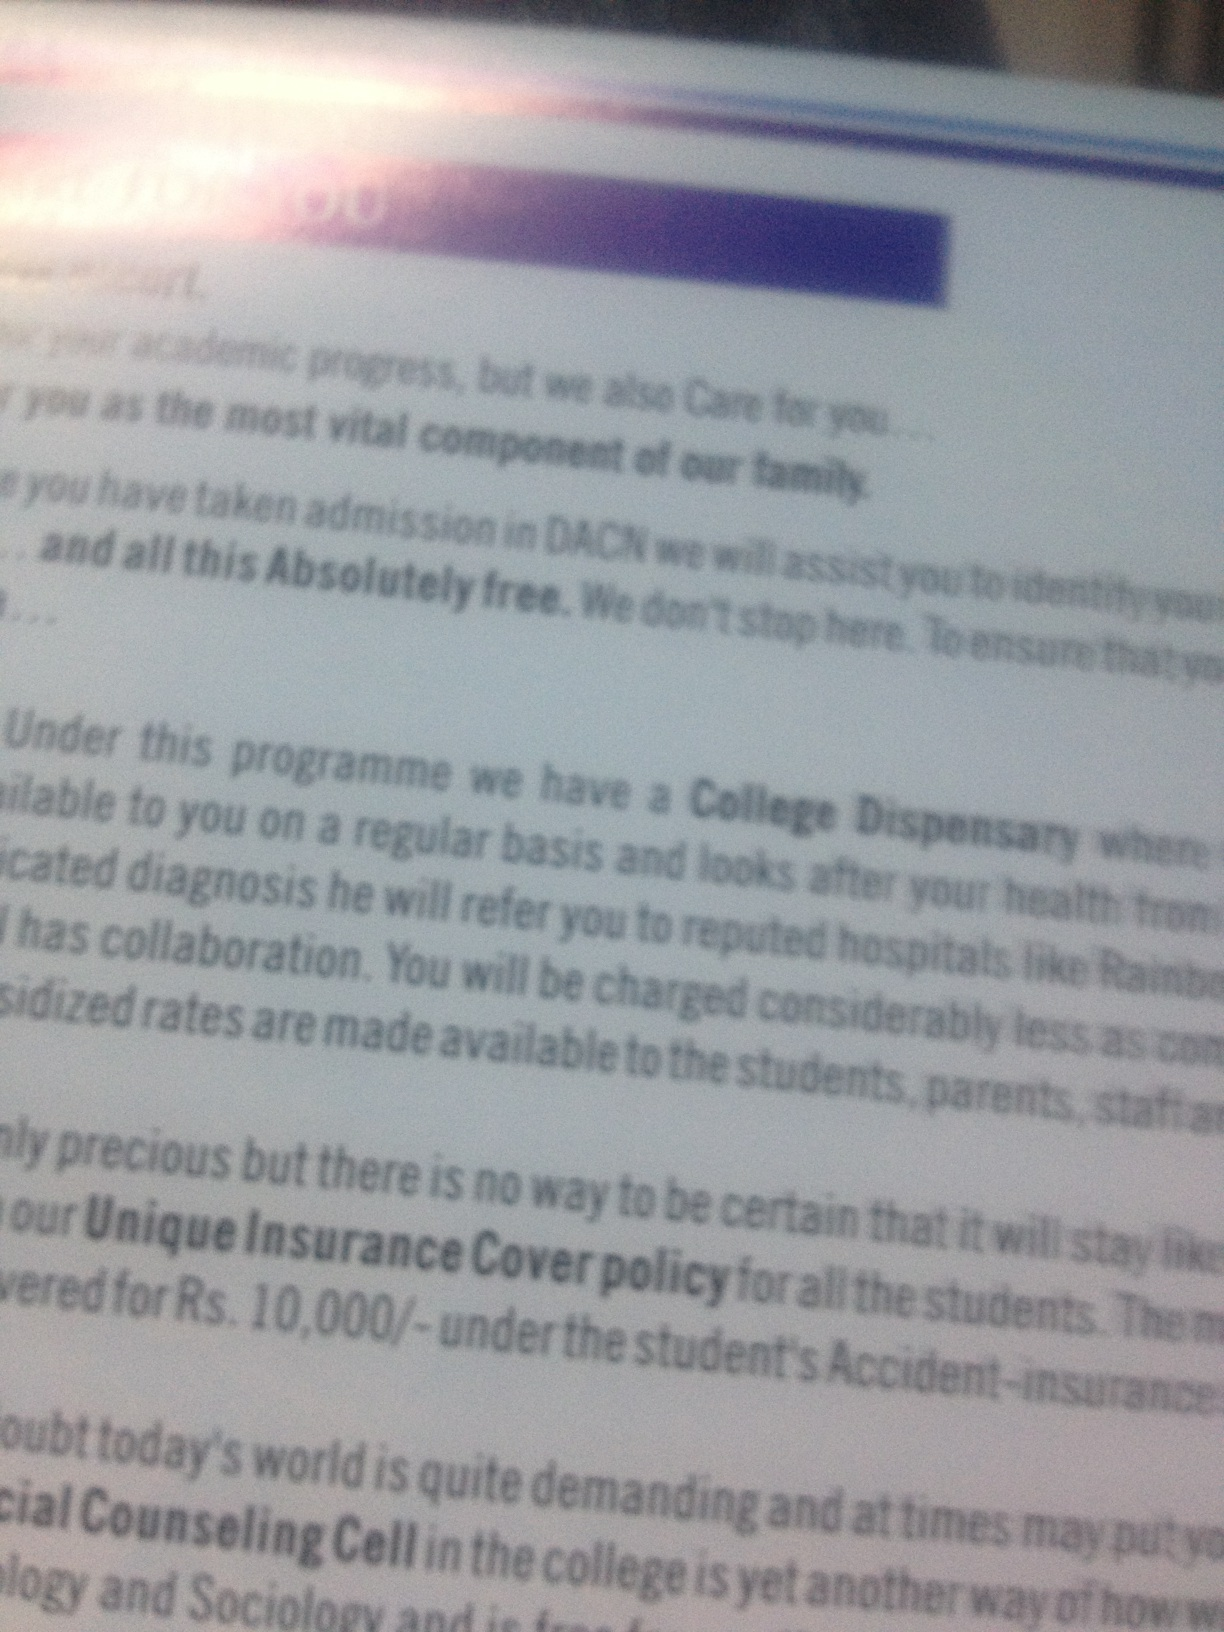Can you describe the main services mentioned on the page? The page appears to describe several student support services, including a College Dispensary that provides healthcare, collaboration with reputed hospitals for referred cases, and a Unique Insurance Cover policy that offers an insurance cover for Rs. 10,000/-. Additionally, there is a mention of a Social Counseling Cell to assist students with psychological and sociological concerns. How does the insurance cover policy benefit the students and their families? The Unique Insurance Cover policy seems to provide a significant benefit by offering coverage worth Rs. 10,000/- under the student's Accident insurance scheme. This can considerably reduce financial burdens on students and their families in case of accidents, ensuring that they receive necessary medical attention without incurring high costs. What are the advantages of having a College Dispensary? Having a College Dispensary offers several advantages: it provides immediate healthcare services to students, faculty, and staff right on campus; it allows for regular health check-ups, treatments, and quick medical attention in emergencies; and it ensures that minor health issues are promptly addressed, improving overall health and wellbeing within the college community. The affiliation with reputed hospitals for more serious cases further enhances the quality and reliability of healthcare services offered. Imagine the College Dispensary is staffed by a team of magical creatures. How would their unique abilities enhance student healthcare? Imagine a College Dispensary staffed by a team of magical creatures: a unicorn could purify and accelerate the healing process with its healing horn, an elf known for herbal knowledge would brew potions that cure various ailments almost instantly, and a phoenix whose tears have incredible healing powers for even the gravest of injuries. There'd be a friendly centaur doctor, offering wisdom in both modern medicine and ancient healing techniques, and tiny sprites that specialize in mental wellness, sprinkling calming fairy dust to alleviate stress and anxiety. This blend of magical abilities would not only ensure swift and miraculous recoveries but also create an enchanting and comforting environment for the students. 